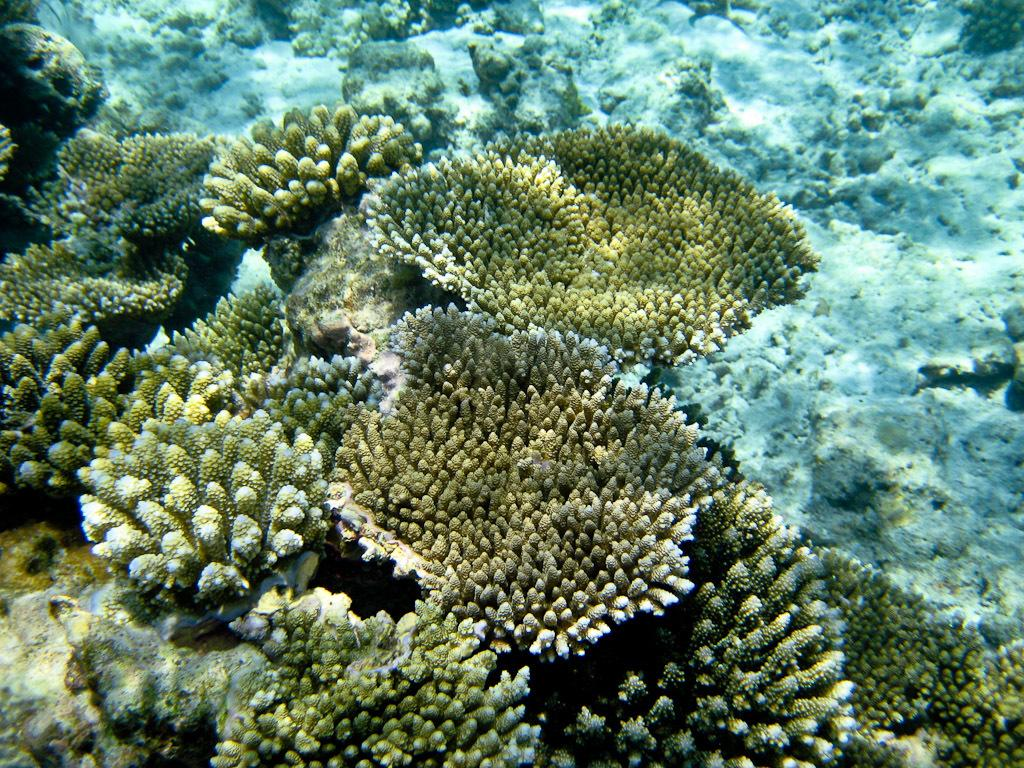What type of environment is shown in the image? The image depicts an underwater environment. Can you describe any specific features of the underwater environment? Unfortunately, the provided facts do not give any specific details about the underwater environment. Are there any living organisms visible in the image? The provided facts do not mention any living organisms in the image. What color is the cough medicine on the table in the image? There is no cough medicine or table present in the image, as it depicts an underwater environment. 